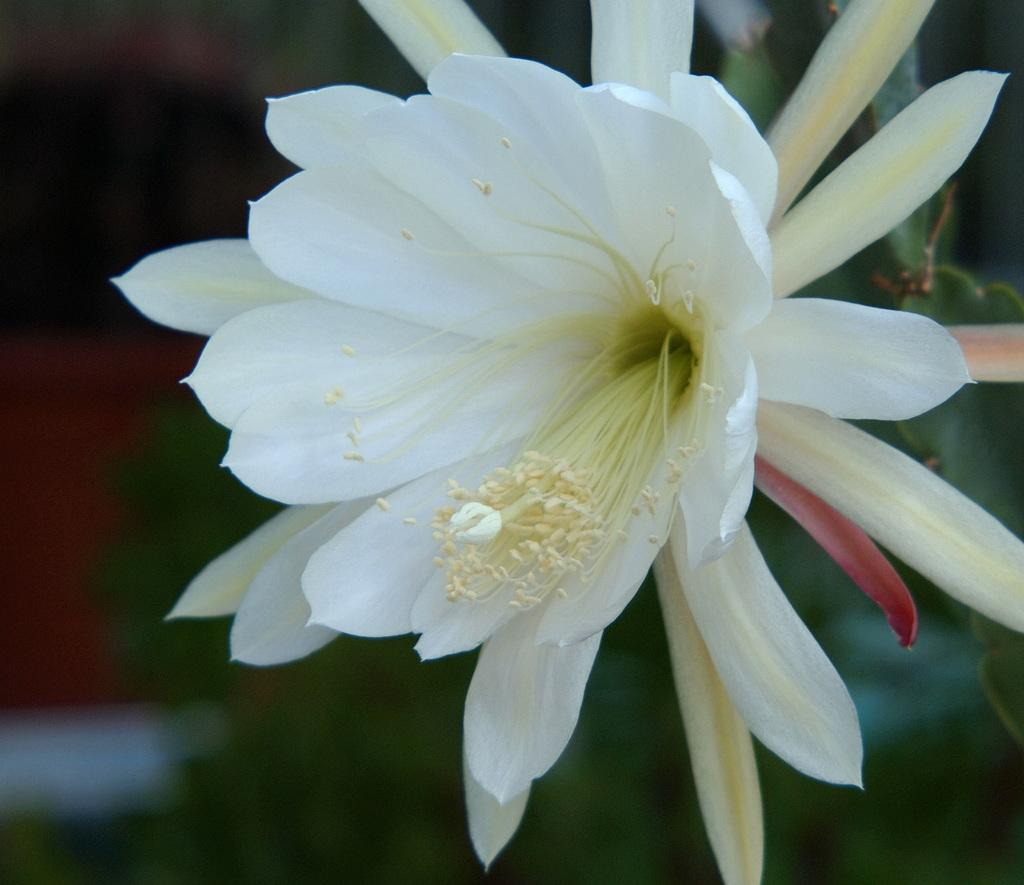What is the main subject of the image? There is a flower in the image. Where is the flower located? The flower is on a plant. What colors can be seen on the flower? The flower has white, cream, and red colors. Can you describe the background of the image? The background of the image is blurred. How many pairs of shoes are visible in the image? There are no shoes present in the image; it features a flower on a plant. What type of song is playing in the background of the image? There is no song playing in the background of the image; it is a still image of a flower on a plant. 